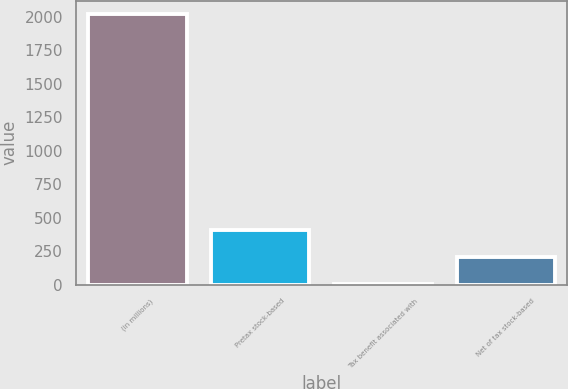<chart> <loc_0><loc_0><loc_500><loc_500><bar_chart><fcel>(in millions)<fcel>Pretax stock-based<fcel>Tax benefit associated with<fcel>Net of tax stock-based<nl><fcel>2016<fcel>408<fcel>6<fcel>207<nl></chart> 